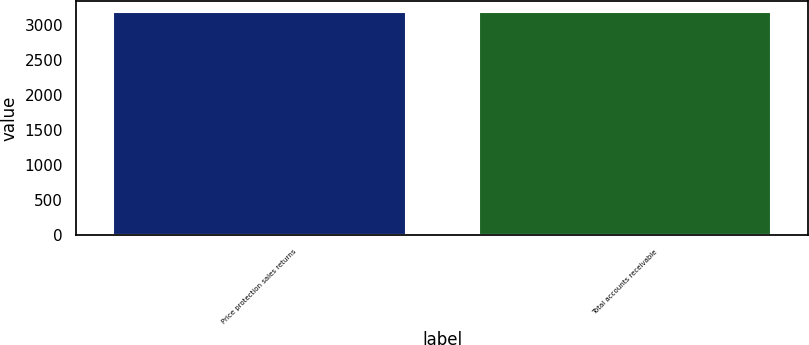Convert chart to OTSL. <chart><loc_0><loc_0><loc_500><loc_500><bar_chart><fcel>Price protection sales returns<fcel>Total accounts receivable<nl><fcel>3191<fcel>3191.1<nl></chart> 